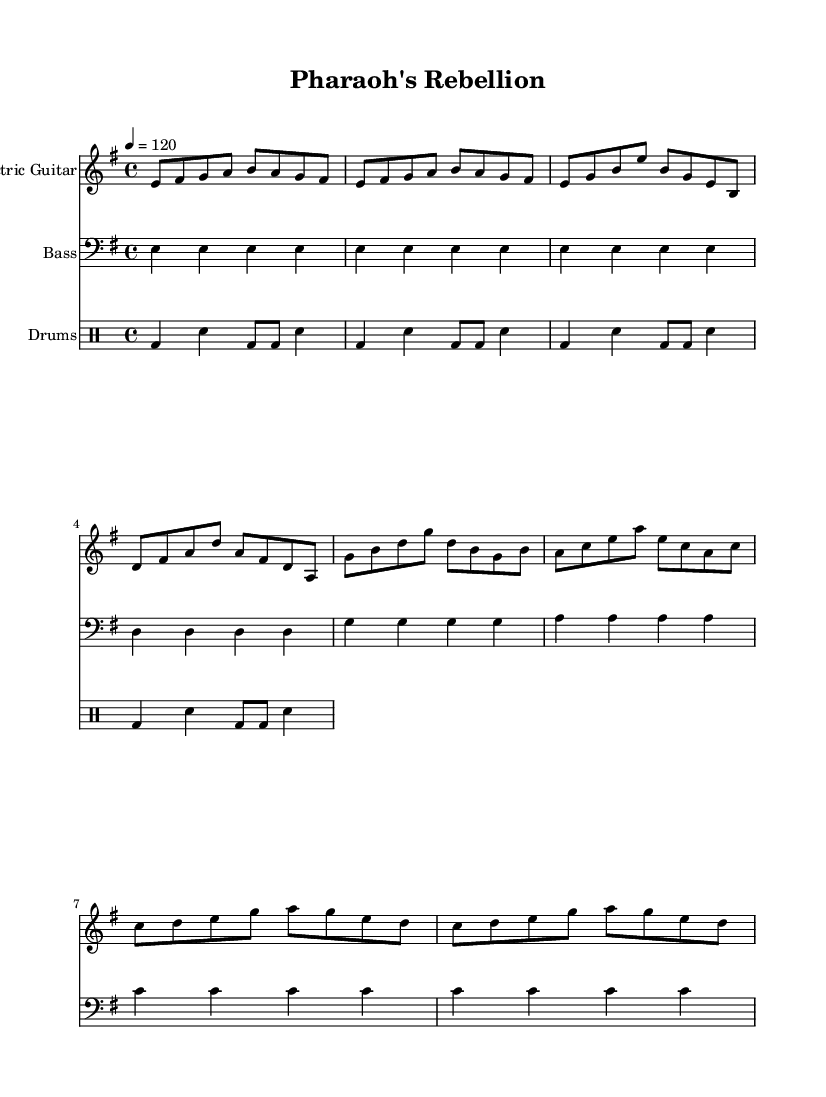What is the key signature of this music? The key signature shown at the beginning of the music indicates E minor, which has one sharp (F#).
Answer: E minor What is the time signature of this music? The time signature indicated is 4/4, which means there are four beats per measure and the quarter note gets one beat.
Answer: 4/4 What is the tempo of the piece? The tempo marking indicates a speed of 120 beats per minute, which is a moderate rock tempo.
Answer: 120 How many measures are in the intro? The intro consists of two measures, as indicated by the grouping of notes at the beginning of the electric guitar part.
Answer: 2 Which section features a bridge? The section identified as the bridge contains a different melodic pattern that stands apart from the verse and chorus, creating contrast and is specifically labeled as the bridge in the arrangement.
Answer: Bridge How many beats does the bass guitar play in the first measure? The first measure of the bass guitar part has four beats, fitting the 4/4 time signature. Each E note in this measure corresponds to one beat.
Answer: 4 What is the main genre of this piece? The overall sound and instruments used, such as electric guitar, bass, and drums, align with the characteristics of rock music, particularly with a blend of traditional Egyptian themes.
Answer: Rock 